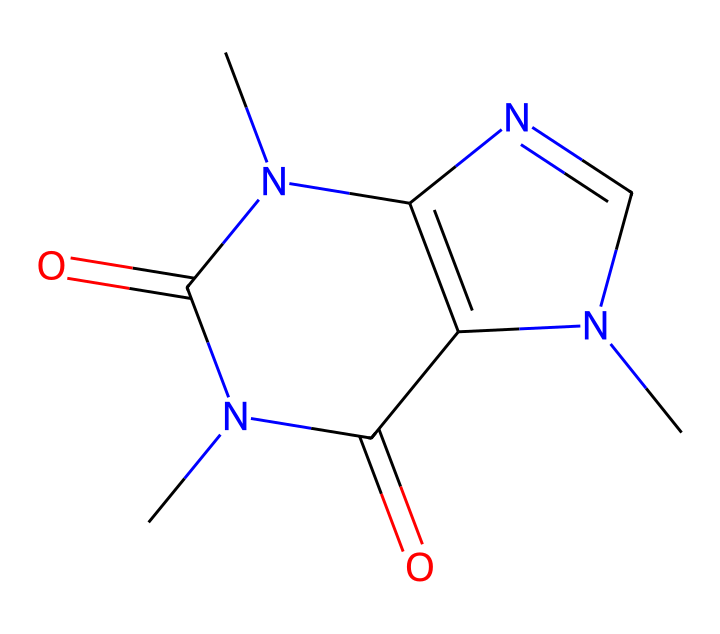What is the name of this chemical? The SMILES representation indicates that the chemical is caffeine, a well-known non-electrolyte found in energy drinks. The structure aligns with the known molecular structure of caffeine.
Answer: caffeine How many nitrogen atoms are in the caffeine structure? By analyzing the SMILES, we can count the nitrogen atoms represented by 'N' in the depiction. There are a total of 4 nitrogen atoms present in the chemical structure of caffeine.
Answer: 4 What is the total number of carbon atoms in this structure? Inspecting the SMILES carefully shows that the carbon atoms are represented by 'C'. Counting these, there are 8 carbon atoms in the caffeine structure.
Answer: 8 Is caffeine polar or non-polar? Based on its chemical structure which consists of multiple nitrogen and oxygen atoms, caffeine is classified as a polar compound due to its ability to form hydrogen bonds and its overall distribution of electron density.
Answer: polar What type of non-electrolyte is caffeine classified as? Caffeine is classified as an alkaloid, which are naturally occurring compounds that predominantly have basic, nitrogenous characteristics and often show biological activity. Caffeine fits this classification.
Answer: alkaloid Does caffeine dissociate in water? Caffeine does not dissociate into ions in water, which is a key characteristic of non-electrolytes. Instead, it remains as intact molecules when dissolved.
Answer: no What effect could caffeine have during coding sessions? Caffeine is known for its stimulating effects, enhancing alertness and concentration, which can be particularly beneficial during long periods of coding or late-night work.
Answer: increase focus 